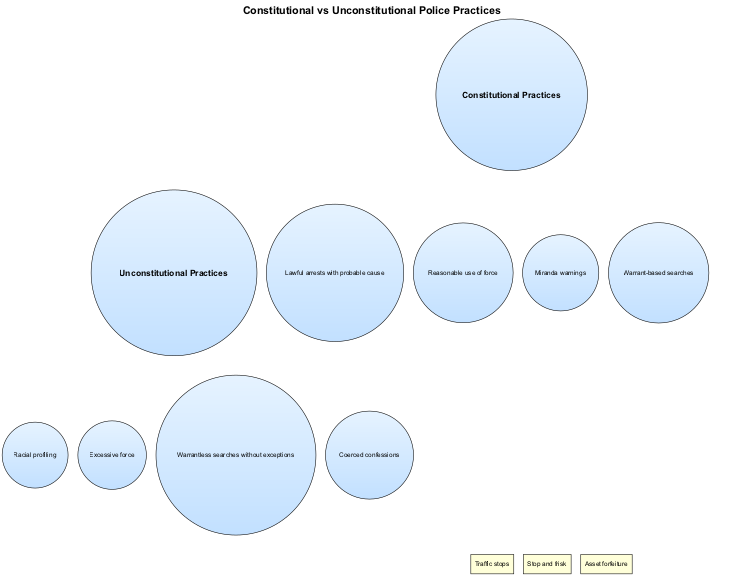What are two constitutional police practices? The diagram lists the elements under "Constitutional Practices," which include "Lawful arrests with probable cause" and "Reasonable use of force." These are found in the left circle of the Venn diagram.
Answer: Lawful arrests with probable cause, Reasonable use of force How many unconstitutional practices are listed? By counting the elements in the "Unconstitutional Practices" circle, there are four items present: "Racial profiling," "Excessive force," "Warrantless searches without exceptions," and "Coerced confessions."
Answer: 4 What is one practice that is common to both constitutional and unconstitutional police practices? The intersection of the two sets contains shared elements, and one of these is "Stop and frisk." This concept is visually placed in the overlapping area of the Venn diagram.
Answer: Stop and frisk Name an unconstitutional practice related to force. Based on the elements listed under "Unconstitutional Practices," one relevant practice is "Excessive force," which is clearly stated in that section of the diagram.
Answer: Excessive force Which constitutional practice involves legal rights at the time of arrest? The "Miranda warnings" are noted as a constitutional practice in the left circle, which informs individuals of their rights during the arrest process. This is critical for understanding lawful procedures and rights protection.
Answer: Miranda warnings What are the number of elements in the intersection of both sets? In the center of the Venn diagram, there are three elements identified, which are "Traffic stops," "Stop and frisk," and "Asset forfeiture." Counting these reveals the total number of shared practices.
Answer: 3 Identify a type of search that is unconstitutional. The diagram indicates "Warrantless searches without exceptions" as one of the practices categorized under "Unconstitutional Practices," which clearly defines an illegal search procedure.
Answer: Warrantless searches without exceptions What is the connection between "Traffic stops" and the police practices? "Traffic stops" are located in the intersection of the two circles, indicating that they can be considered both constitutional and potentially unconstitutional, depending on the context of their execution.
Answer: Traffic stops 